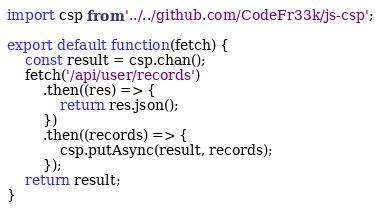Convert code to text. <code><loc_0><loc_0><loc_500><loc_500><_JavaScript_>import csp from '../../github.com/CodeFr33k/js-csp';

export default function(fetch) {
    const result = csp.chan();
    fetch('/api/user/records')
        .then((res) => {
            return res.json();
        })
        .then((records) => {
            csp.putAsync(result, records);
        });
    return result;
}

</code> 